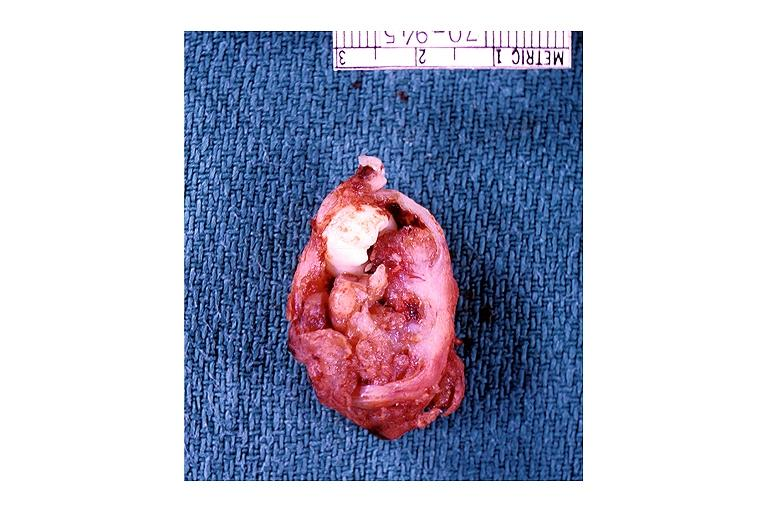does this image show adenomatoid odontogenic tumor?
Answer the question using a single word or phrase. Yes 